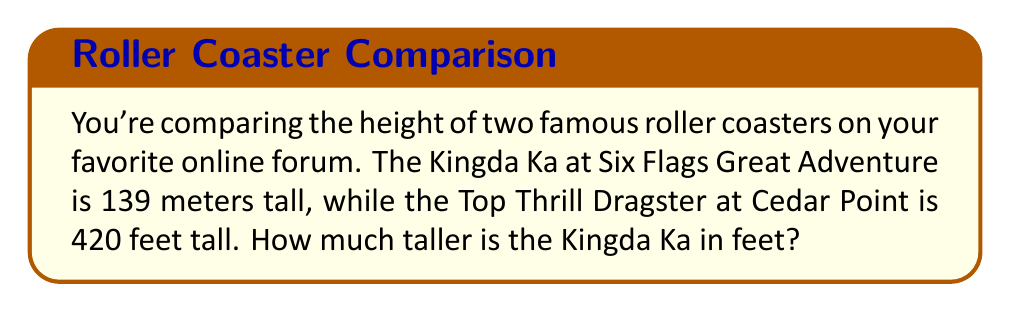Can you solve this math problem? To solve this problem, we need to convert the height of Kingda Ka from meters to feet and then compare it with the height of Top Thrill Dragster. Let's break it down step-by-step:

1. Convert Kingda Ka's height from meters to feet:
   We know that 1 meter is approximately equal to 3.28084 feet.
   
   $$139 \text{ meters} \times 3.28084 \frac{\text{feet}}{\text{meter}} = 456.03676 \text{ feet}$$

2. Round the result to the nearest foot:
   $$456.03676 \text{ feet} \approx 456 \text{ feet}$$

3. Calculate the difference in height:
   $$456 \text{ feet} - 420 \text{ feet} = 36 \text{ feet}$$

Therefore, the Kingda Ka is 36 feet taller than the Top Thrill Dragster.
Answer: 36 feet 